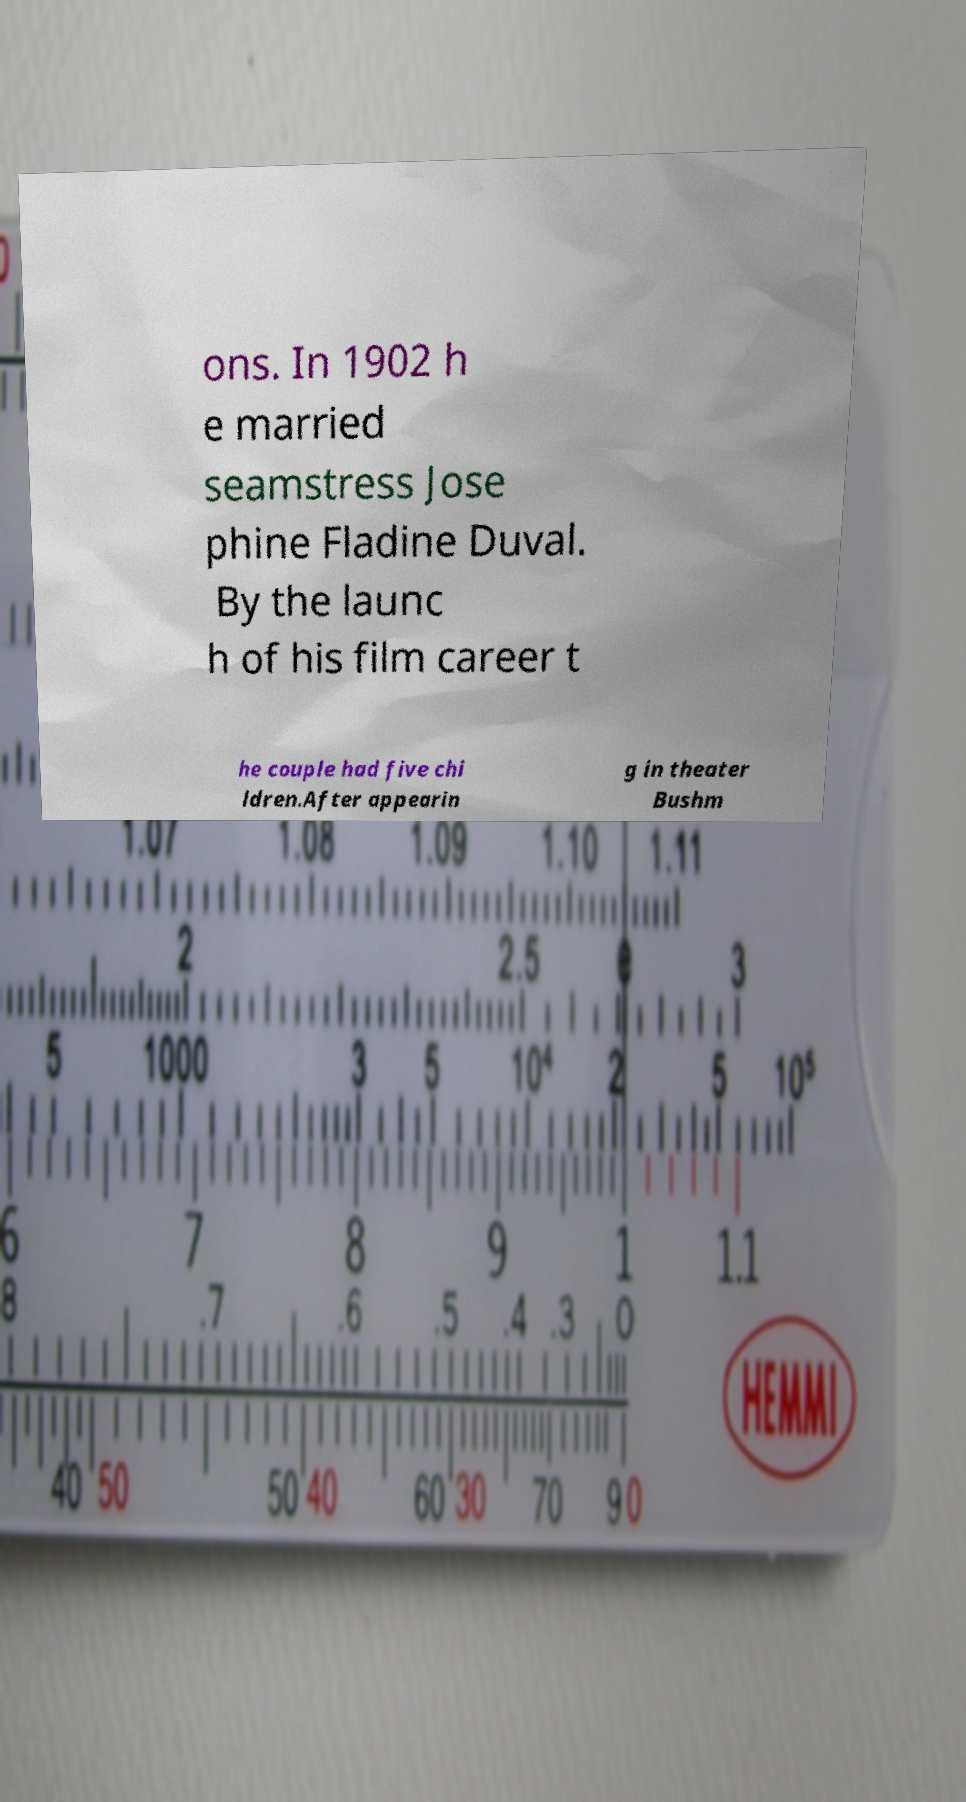Please read and relay the text visible in this image. What does it say? ons. In 1902 h e married seamstress Jose phine Fladine Duval. By the launc h of his film career t he couple had five chi ldren.After appearin g in theater Bushm 